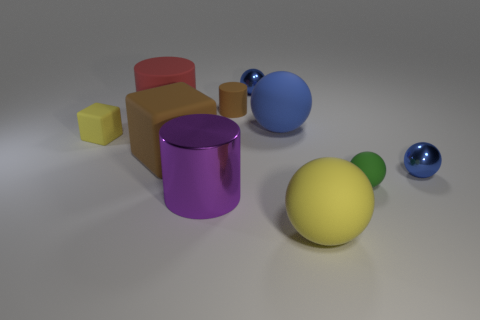How many blue spheres must be subtracted to get 1 blue spheres? 2 Subtract all tiny rubber spheres. How many spheres are left? 4 Subtract all green balls. How many balls are left? 4 Subtract all blocks. How many objects are left? 8 Subtract all brown balls. Subtract all green cubes. How many balls are left? 5 Subtract all cyan balls. How many red cylinders are left? 1 Subtract all green things. Subtract all big metal cylinders. How many objects are left? 8 Add 1 matte blocks. How many matte blocks are left? 3 Add 1 big purple shiny cylinders. How many big purple shiny cylinders exist? 2 Subtract 0 gray cubes. How many objects are left? 10 